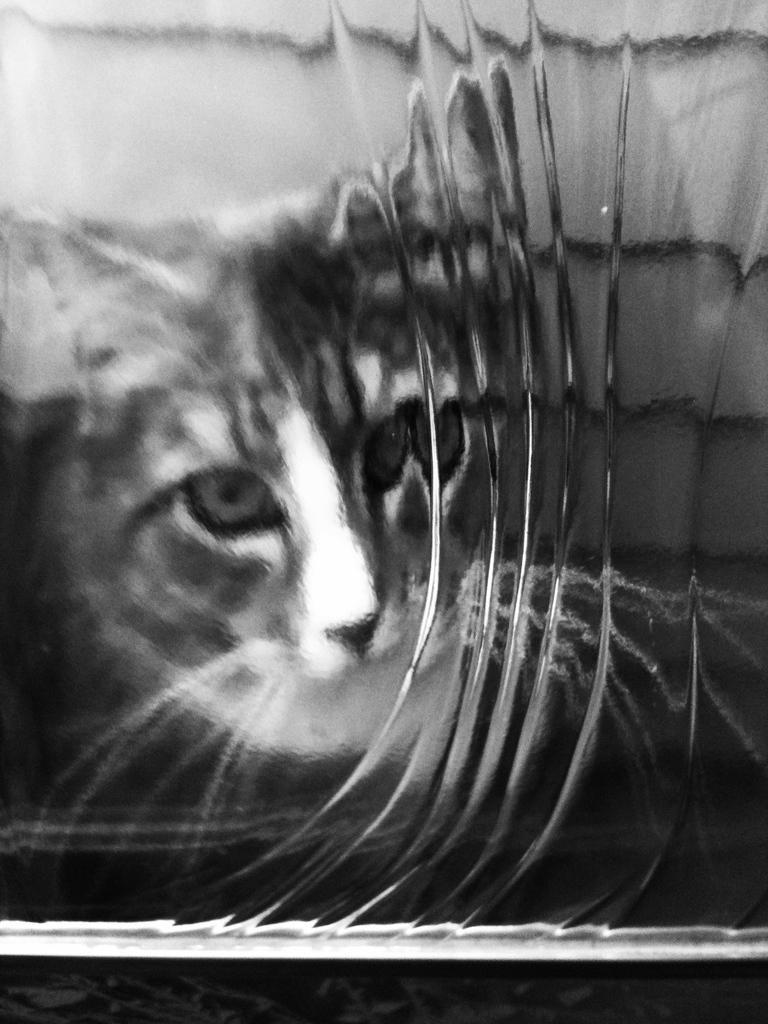Please provide a concise description of this image. This picture is a black and white image. In this image we can see one object looks like a mirror. In this mirror, we can see the reflection of a cat and the bottom of the image is dark. 